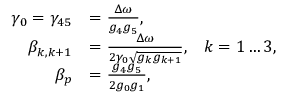<formula> <loc_0><loc_0><loc_500><loc_500>\begin{array} { r l } { \gamma _ { 0 } = \gamma _ { 4 5 } } & { = \frac { \Delta \omega } { g _ { 4 } g _ { 5 } } , } \\ { \beta _ { k , k + 1 } } & { = \frac { \Delta \omega } { 2 \gamma _ { 0 } \sqrt { g _ { k } g _ { k + 1 } } } , \, k = 1 \dots 3 , } \\ { \beta _ { p } } & { = \frac { g _ { 4 } g _ { 5 } } { 2 g _ { 0 } g _ { 1 } } , } \end{array}</formula> 